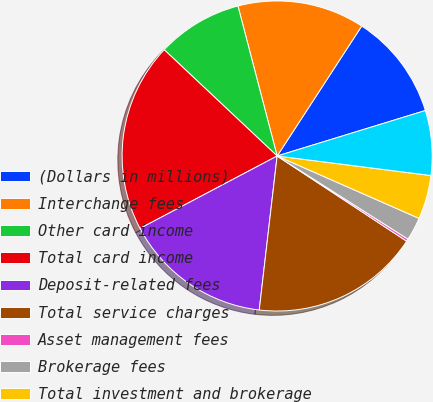Convert chart to OTSL. <chart><loc_0><loc_0><loc_500><loc_500><pie_chart><fcel>(Dollars in millions)<fcel>Interchange fees<fcel>Other card income<fcel>Total card income<fcel>Deposit-related fees<fcel>Total service charges<fcel>Asset management fees<fcel>Brokerage fees<fcel>Total investment and brokerage<fcel>Other income<nl><fcel>11.08%<fcel>13.25%<fcel>8.92%<fcel>19.75%<fcel>15.42%<fcel>17.58%<fcel>0.25%<fcel>2.42%<fcel>4.58%<fcel>6.75%<nl></chart> 